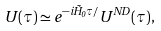Convert formula to latex. <formula><loc_0><loc_0><loc_500><loc_500>U ( \tau ) \simeq e ^ { - i \tilde { H } _ { 0 } \tau / } U ^ { N D } ( \tau ) ,</formula> 